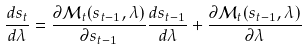Convert formula to latex. <formula><loc_0><loc_0><loc_500><loc_500>\frac { d s _ { t } } { d \lambda } = \frac { \partial \mathcal { M } _ { t } ( s _ { t - 1 } , \lambda ) } { \partial s _ { t - 1 } } \frac { d s _ { t - 1 } } { d \lambda } + \frac { \partial \mathcal { M } _ { t } ( s _ { t - 1 } , \lambda ) } { \partial \lambda }</formula> 